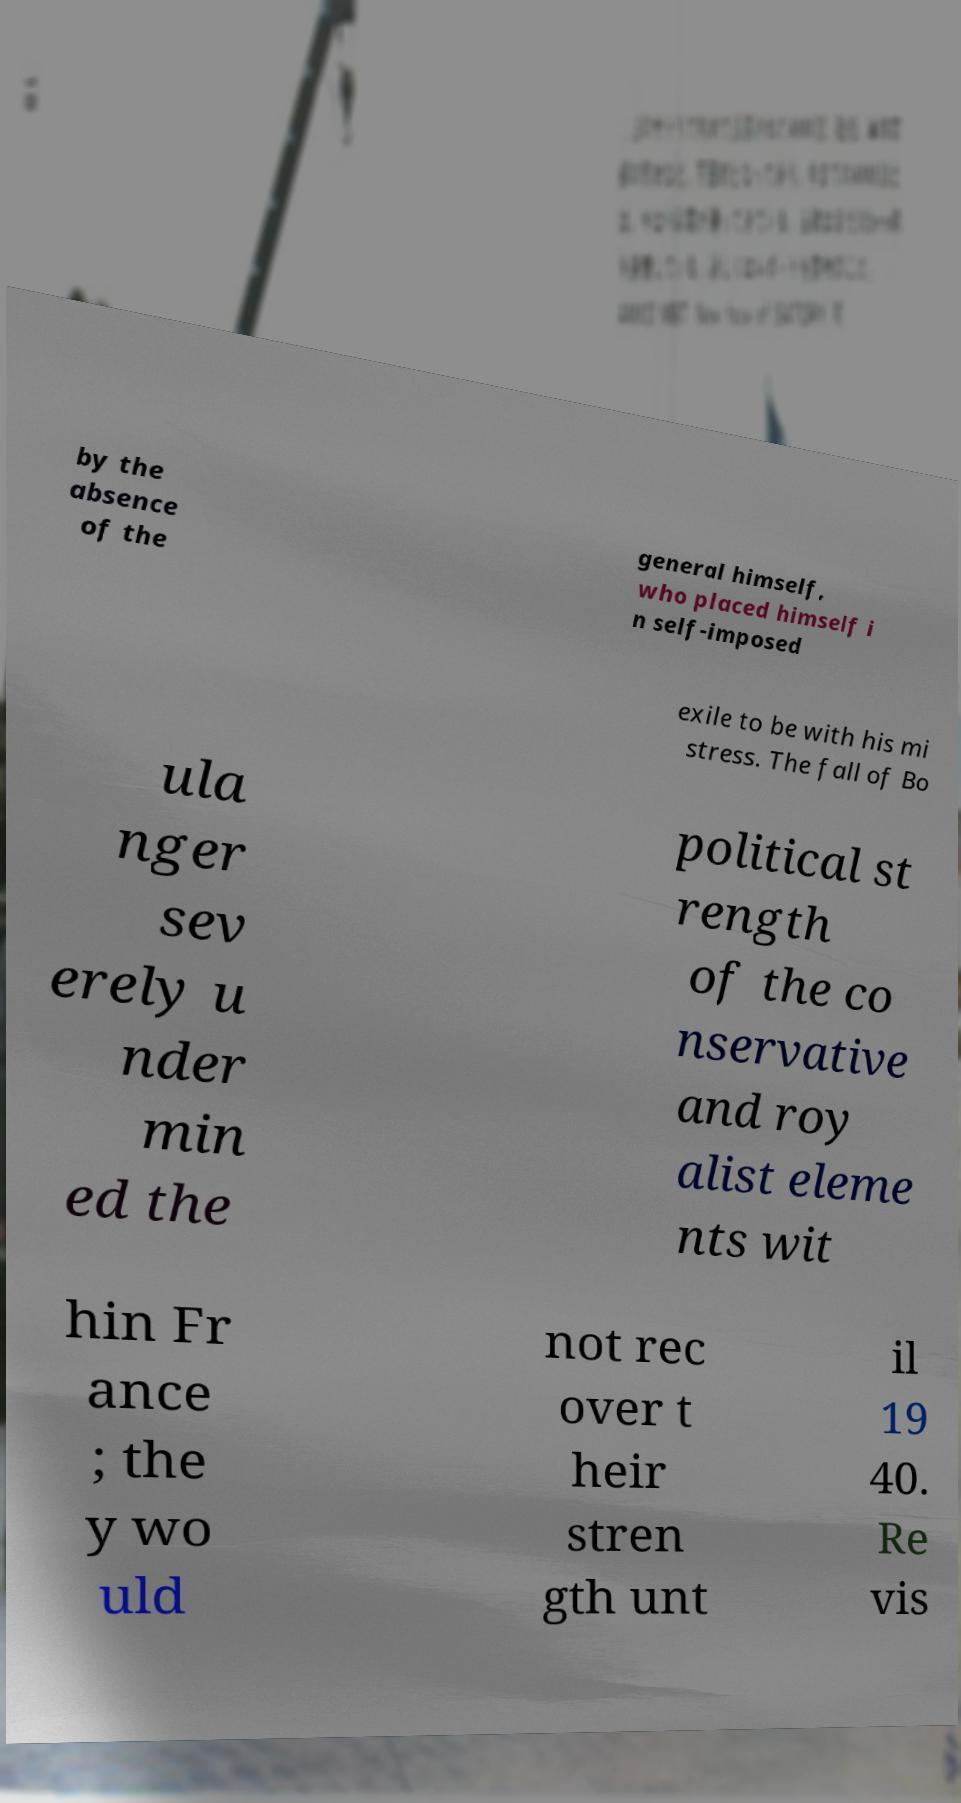Can you accurately transcribe the text from the provided image for me? by the absence of the general himself, who placed himself i n self-imposed exile to be with his mi stress. The fall of Bo ula nger sev erely u nder min ed the political st rength of the co nservative and roy alist eleme nts wit hin Fr ance ; the y wo uld not rec over t heir stren gth unt il 19 40. Re vis 